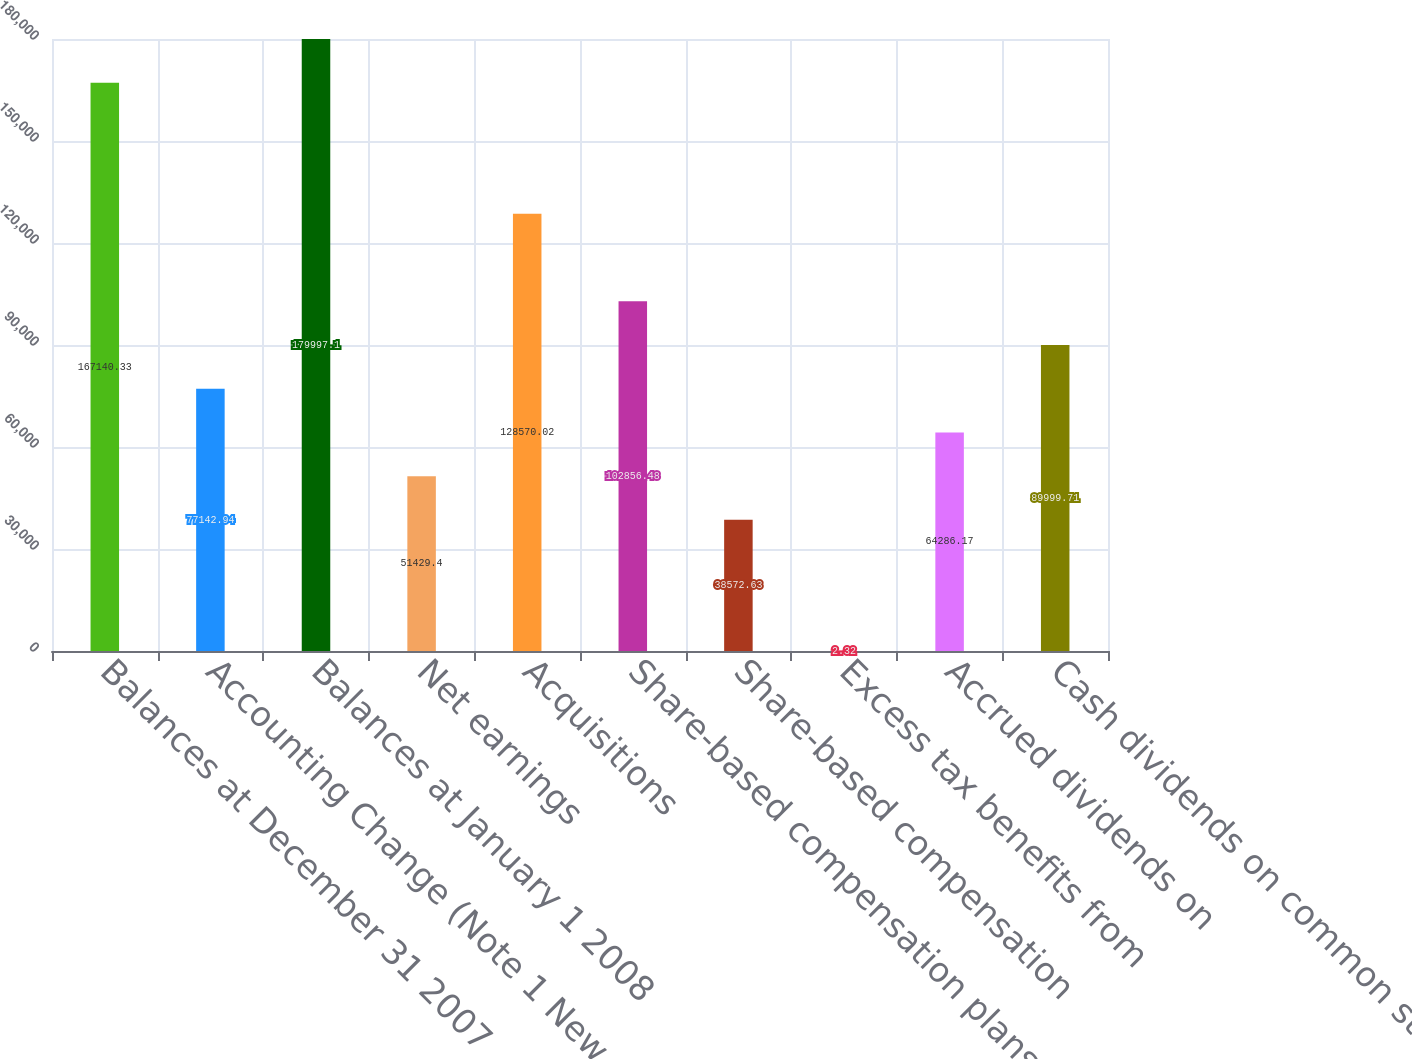Convert chart. <chart><loc_0><loc_0><loc_500><loc_500><bar_chart><fcel>Balances at December 31 2007<fcel>Accounting Change (Note 1 New<fcel>Balances at January 1 2008<fcel>Net earnings<fcel>Acquisitions<fcel>Share-based compensation plans<fcel>Share-based compensation<fcel>Excess tax benefits from<fcel>Accrued dividends on<fcel>Cash dividends on common stock<nl><fcel>167140<fcel>77142.9<fcel>179997<fcel>51429.4<fcel>128570<fcel>102856<fcel>38572.6<fcel>2.32<fcel>64286.2<fcel>89999.7<nl></chart> 